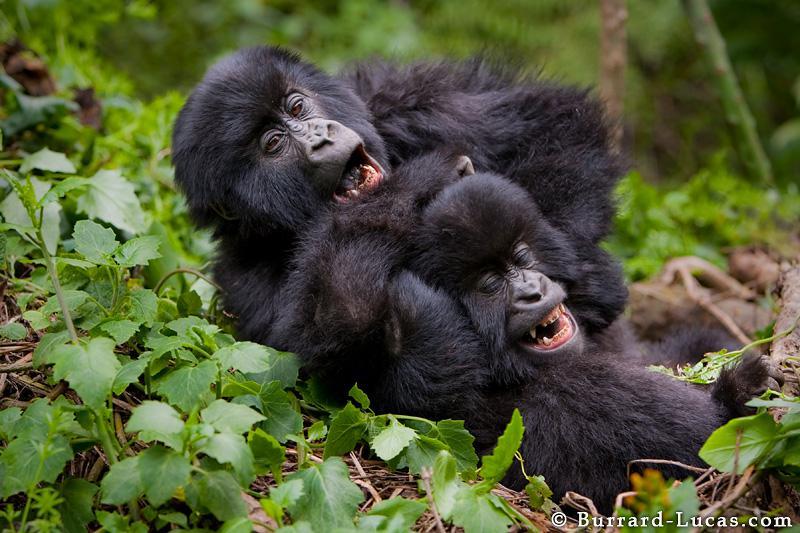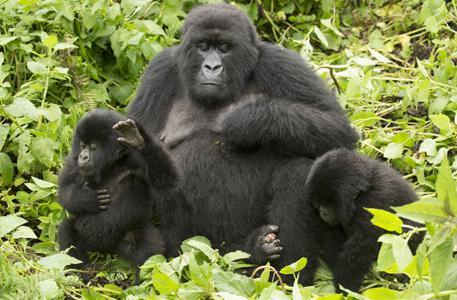The first image is the image on the left, the second image is the image on the right. Analyze the images presented: Is the assertion "to the left, two simians appear to be playfully irritated at each other." valid? Answer yes or no. Yes. The first image is the image on the left, the second image is the image on the right. Analyze the images presented: Is the assertion "An image shows exactly two furry apes wrestling each other, both with wide-open mouths." valid? Answer yes or no. Yes. 